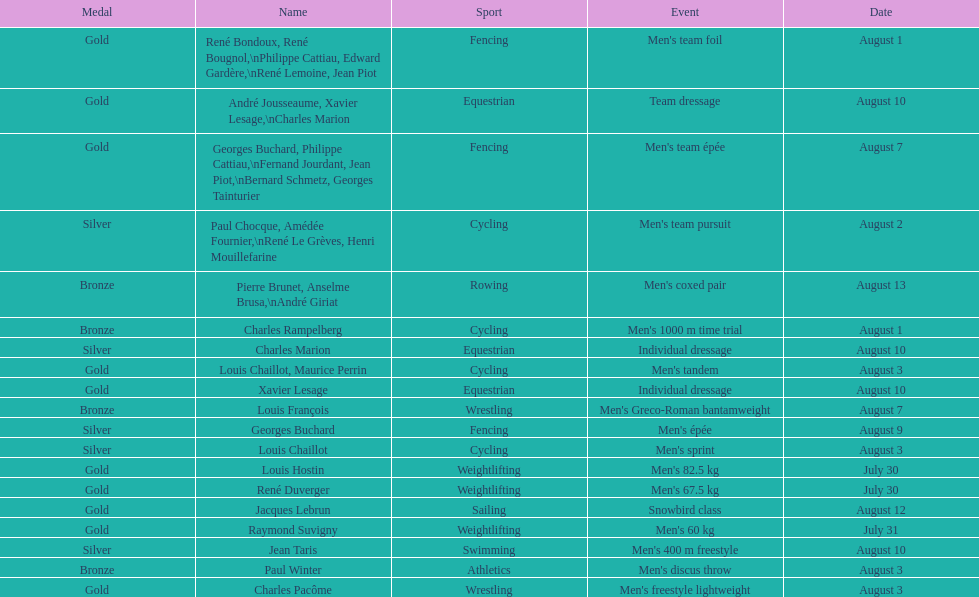What sport did louis challiot win the same medal as paul chocque in? Cycling. Could you help me parse every detail presented in this table? {'header': ['Medal', 'Name', 'Sport', 'Event', 'Date'], 'rows': [['Gold', 'René Bondoux, René Bougnol,\\nPhilippe Cattiau, Edward Gardère,\\nRené Lemoine, Jean Piot', 'Fencing', "Men's team foil", 'August 1'], ['Gold', 'André Jousseaume, Xavier Lesage,\\nCharles Marion', 'Equestrian', 'Team dressage', 'August 10'], ['Gold', 'Georges Buchard, Philippe Cattiau,\\nFernand Jourdant, Jean Piot,\\nBernard Schmetz, Georges Tainturier', 'Fencing', "Men's team épée", 'August 7'], ['Silver', 'Paul Chocque, Amédée Fournier,\\nRené Le Grèves, Henri Mouillefarine', 'Cycling', "Men's team pursuit", 'August 2'], ['Bronze', 'Pierre Brunet, Anselme Brusa,\\nAndré Giriat', 'Rowing', "Men's coxed pair", 'August 13'], ['Bronze', 'Charles Rampelberg', 'Cycling', "Men's 1000 m time trial", 'August 1'], ['Silver', 'Charles Marion', 'Equestrian', 'Individual dressage', 'August 10'], ['Gold', 'Louis Chaillot, Maurice Perrin', 'Cycling', "Men's tandem", 'August 3'], ['Gold', 'Xavier Lesage', 'Equestrian', 'Individual dressage', 'August 10'], ['Bronze', 'Louis François', 'Wrestling', "Men's Greco-Roman bantamweight", 'August 7'], ['Silver', 'Georges Buchard', 'Fencing', "Men's épée", 'August 9'], ['Silver', 'Louis Chaillot', 'Cycling', "Men's sprint", 'August 3'], ['Gold', 'Louis Hostin', 'Weightlifting', "Men's 82.5 kg", 'July 30'], ['Gold', 'René Duverger', 'Weightlifting', "Men's 67.5 kg", 'July 30'], ['Gold', 'Jacques Lebrun', 'Sailing', 'Snowbird class', 'August 12'], ['Gold', 'Raymond Suvigny', 'Weightlifting', "Men's 60 kg", 'July 31'], ['Silver', 'Jean Taris', 'Swimming', "Men's 400 m freestyle", 'August 10'], ['Bronze', 'Paul Winter', 'Athletics', "Men's discus throw", 'August 3'], ['Gold', 'Charles Pacôme', 'Wrestling', "Men's freestyle lightweight", 'August 3']]} 